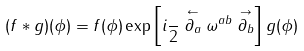<formula> <loc_0><loc_0><loc_500><loc_500>( f \ast g ) ( \phi ) = f ( \phi ) \exp \left [ i \frac { } { 2 } \stackrel { \leftarrow } { \partial _ { a } } { \omega } ^ { a b } \stackrel { \rightarrow } { \partial _ { b } } \right ] g ( \phi )</formula> 